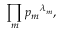Convert formula to latex. <formula><loc_0><loc_0><loc_500><loc_500>\prod _ { m } { p _ { m } } ^ { \lambda _ { m } } ,</formula> 